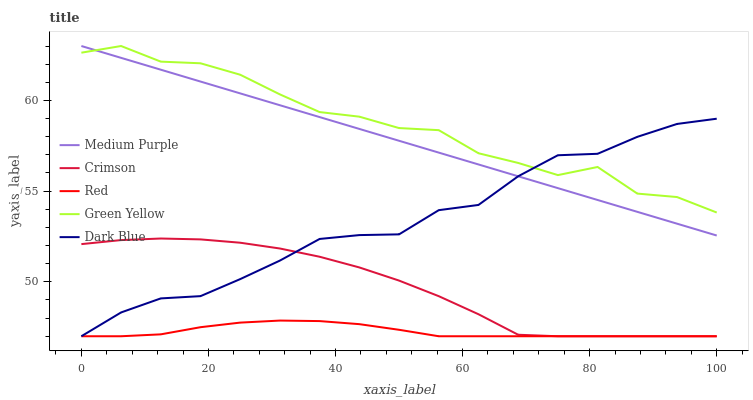Does Red have the minimum area under the curve?
Answer yes or no. Yes. Does Green Yellow have the maximum area under the curve?
Answer yes or no. Yes. Does Crimson have the minimum area under the curve?
Answer yes or no. No. Does Crimson have the maximum area under the curve?
Answer yes or no. No. Is Medium Purple the smoothest?
Answer yes or no. Yes. Is Green Yellow the roughest?
Answer yes or no. Yes. Is Crimson the smoothest?
Answer yes or no. No. Is Crimson the roughest?
Answer yes or no. No. Does Green Yellow have the lowest value?
Answer yes or no. No. Does Green Yellow have the highest value?
Answer yes or no. Yes. Does Crimson have the highest value?
Answer yes or no. No. Is Crimson less than Green Yellow?
Answer yes or no. Yes. Is Medium Purple greater than Crimson?
Answer yes or no. Yes. Does Crimson intersect Green Yellow?
Answer yes or no. No. 